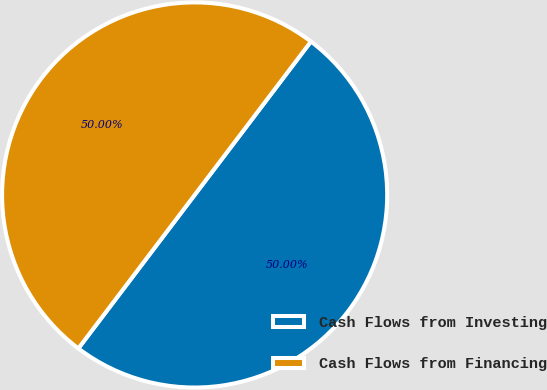Convert chart. <chart><loc_0><loc_0><loc_500><loc_500><pie_chart><fcel>Cash Flows from Investing<fcel>Cash Flows from Financing<nl><fcel>50.0%<fcel>50.0%<nl></chart> 